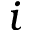<formula> <loc_0><loc_0><loc_500><loc_500>i</formula> 